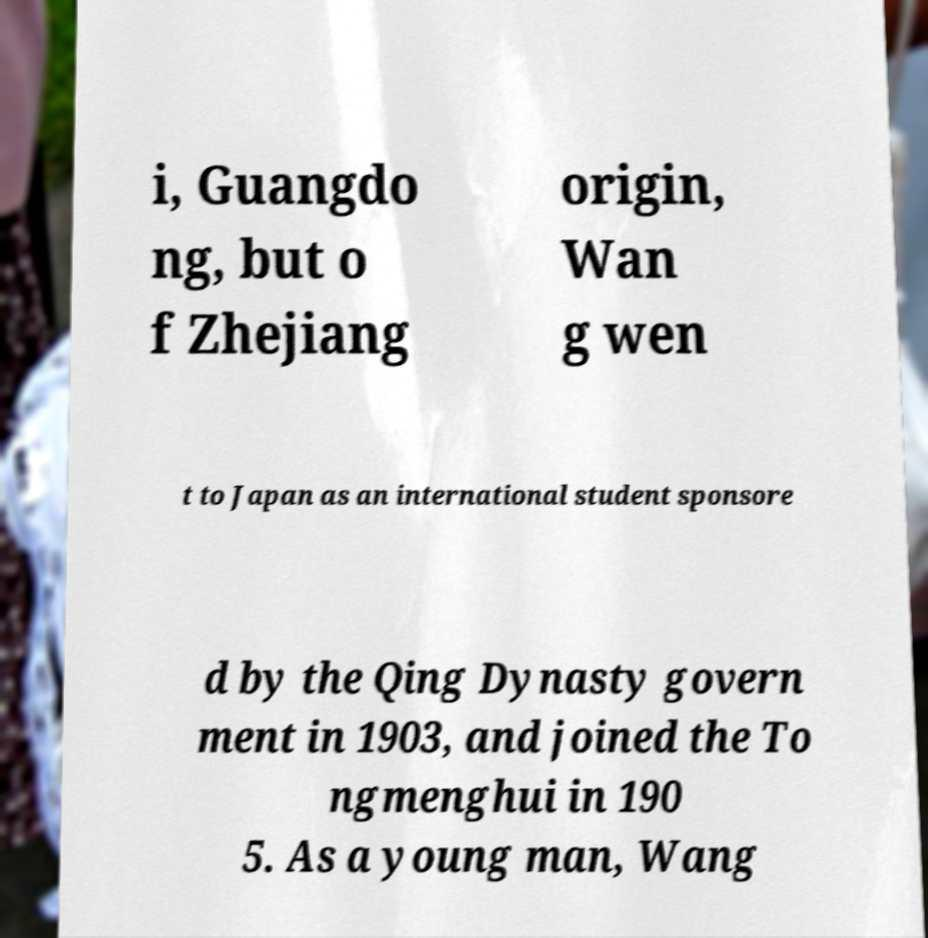Please identify and transcribe the text found in this image. i, Guangdo ng, but o f Zhejiang origin, Wan g wen t to Japan as an international student sponsore d by the Qing Dynasty govern ment in 1903, and joined the To ngmenghui in 190 5. As a young man, Wang 